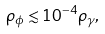<formula> <loc_0><loc_0><loc_500><loc_500>\rho _ { \phi } \lesssim 1 0 ^ { - 4 } \rho _ { \gamma } ,</formula> 